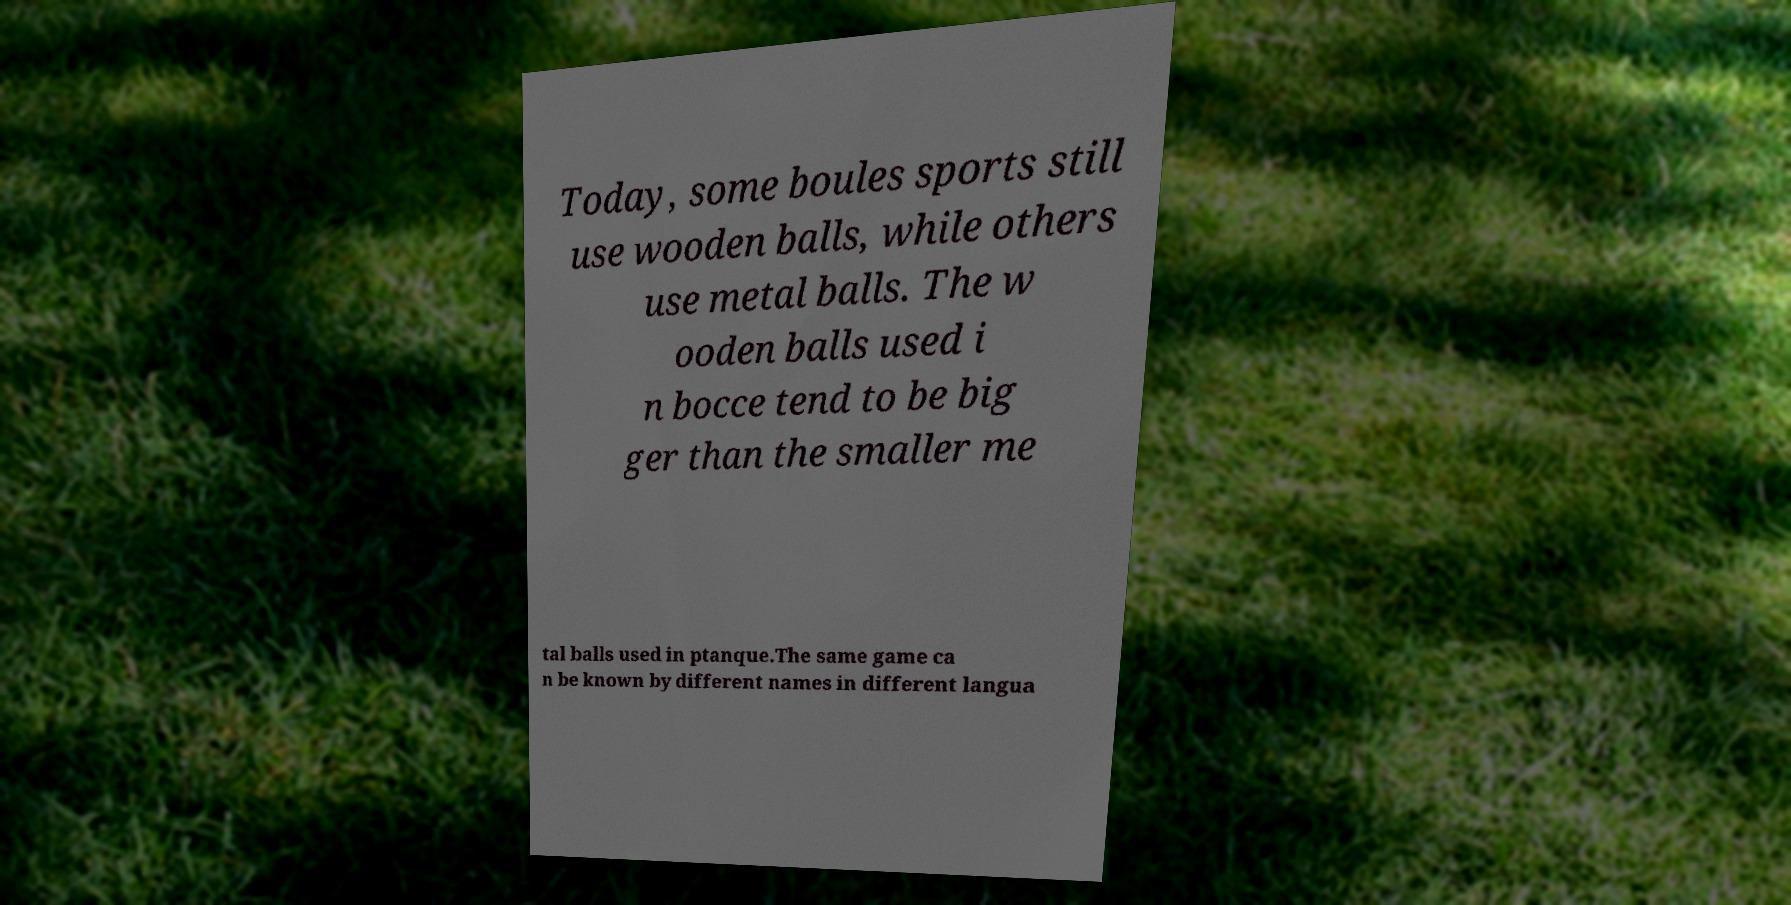There's text embedded in this image that I need extracted. Can you transcribe it verbatim? Today, some boules sports still use wooden balls, while others use metal balls. The w ooden balls used i n bocce tend to be big ger than the smaller me tal balls used in ptanque.The same game ca n be known by different names in different langua 